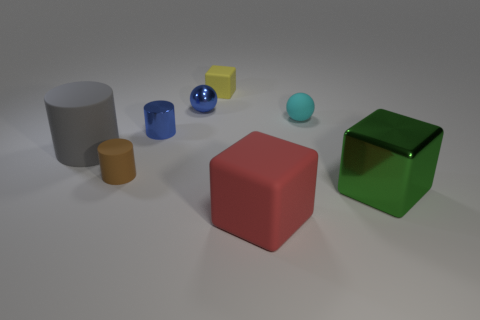Add 1 small metal spheres. How many objects exist? 9 Subtract all balls. How many objects are left? 6 Add 3 tiny yellow cubes. How many tiny yellow cubes exist? 4 Subtract 0 cyan cylinders. How many objects are left? 8 Subtract all tiny yellow blocks. Subtract all metallic spheres. How many objects are left? 6 Add 4 big cylinders. How many big cylinders are left? 5 